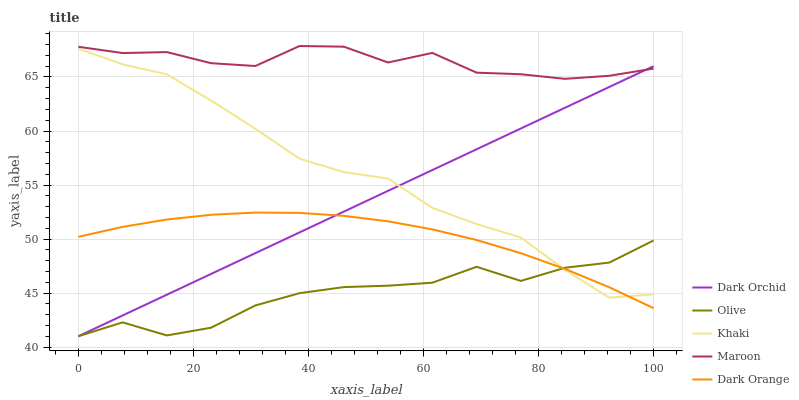Does Olive have the minimum area under the curve?
Answer yes or no. Yes. Does Maroon have the maximum area under the curve?
Answer yes or no. Yes. Does Dark Orange have the minimum area under the curve?
Answer yes or no. No. Does Dark Orange have the maximum area under the curve?
Answer yes or no. No. Is Dark Orchid the smoothest?
Answer yes or no. Yes. Is Olive the roughest?
Answer yes or no. Yes. Is Dark Orange the smoothest?
Answer yes or no. No. Is Dark Orange the roughest?
Answer yes or no. No. Does Dark Orange have the lowest value?
Answer yes or no. No. Does Maroon have the highest value?
Answer yes or no. Yes. Does Dark Orange have the highest value?
Answer yes or no. No. Is Khaki less than Maroon?
Answer yes or no. Yes. Is Maroon greater than Khaki?
Answer yes or no. Yes. Does Olive intersect Khaki?
Answer yes or no. Yes. Is Olive less than Khaki?
Answer yes or no. No. Is Olive greater than Khaki?
Answer yes or no. No. Does Khaki intersect Maroon?
Answer yes or no. No. 